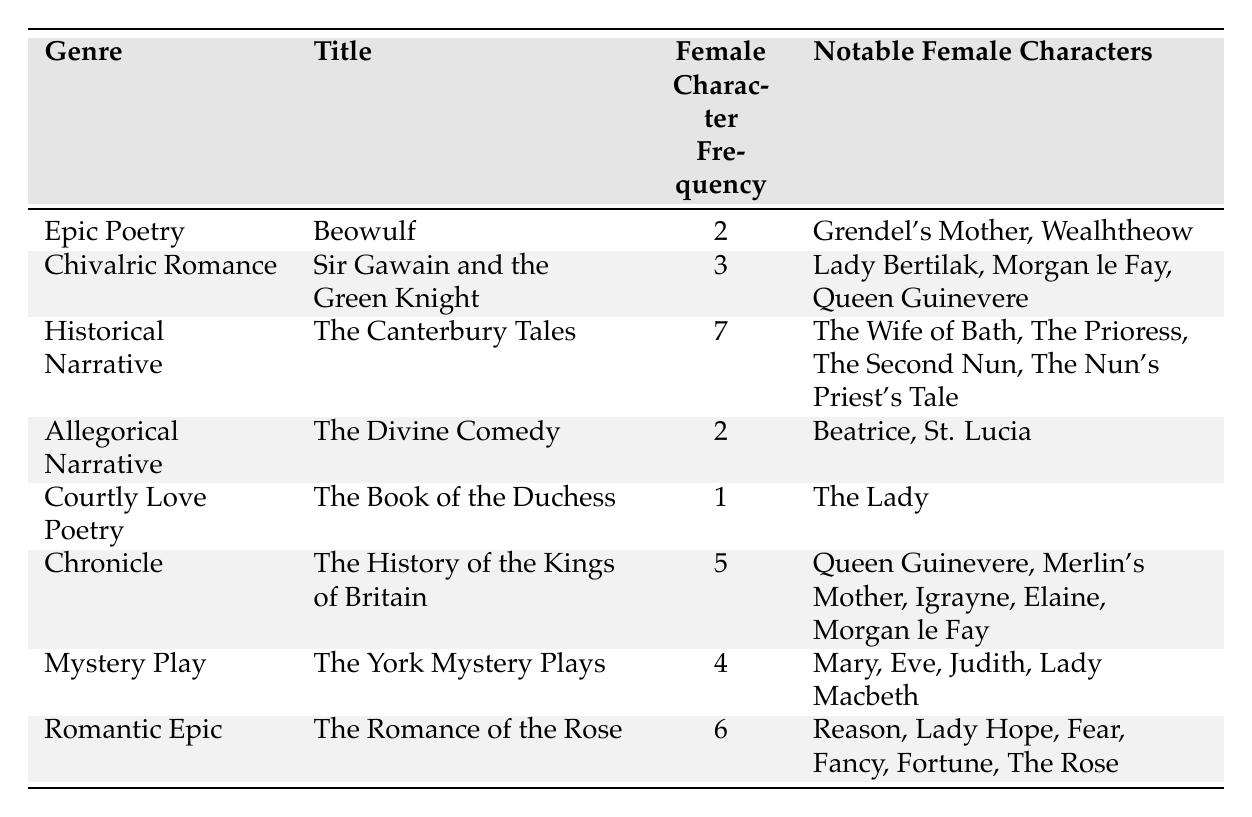What is the genre with the highest frequency of female characters? The table shows that "The Canterbury Tales" under the genre "Historical Narrative" has the highest frequency of female characters with a count of 7.
Answer: Historical Narrative How many notable female characters are there in "The Romance of the Rose"? In the table, it states that "The Romance of the Rose" has 6 notable female characters listed: Reason, Lady Hope, Fear, Fancy, Fortune, and The Rose.
Answer: 6 Which genre has the least number of female characters? The table indicates that "The Book of the Duchess," part of the Courtly Love Poetry genre, has the least number of female characters, totaling only 1.
Answer: Courtly Love Poetry If we consider the frequency of female characters across genres, what is the average frequency? To find the average, we sum the female character frequencies (2 + 3 + 7 + 2 + 1 + 5 + 4 + 6 = 30) and divide by the number of genres (8), resulting in an average frequency of 30/8 = 3.75.
Answer: 3.75 Is "Lady Macbeth" listed as a notable female character in any genre? The table confirms that "Lady Macbeth" is noted as a female character in the genre "Mystery Play," specifically in "The York Mystery Plays."
Answer: Yes How many more female characters are present in "The Canterbury Tales" compared to "Beowulf"? "The Canterbury Tales" has 7 female characters, while "Beowulf" has 2. The difference in frequency is 7 - 2 = 5.
Answer: 5 What is the total frequency of female characters in the genres of Epic Poetry and Allegorical Narrative combined? The total frequency for Epic Poetry "Beowulf" is 2 and for Allegorical Narrative "The Divine Comedy" is 2. Adding these gives 2 + 2 = 4.
Answer: 4 Among the notable female characters listed, which character appears in the most genres? By reviewing the table, "Queen Guinevere" appears in both "Chronic" and "Chivalric Romance." This suggests she is notably recognized in multiple genres, making her one of the often cited characters. However, no character appears in more than these two.
Answer: Queen Guinevere 